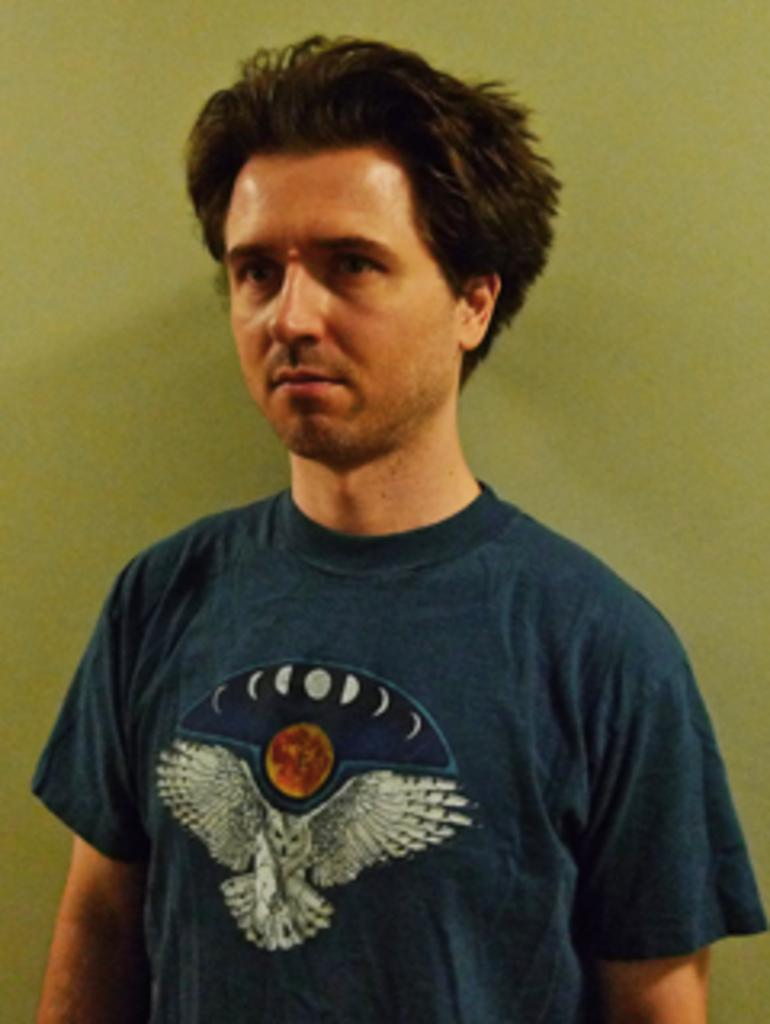Who is the main subject in the image? There is a person in the center of the image. What is the person wearing? The person is wearing a t-shirt. Can you describe the design on the t-shirt? There is an image of a bird on the t-shirt. What can be seen in the background of the image? There is a wall in the background of the image. What type of wilderness can be seen in the image? There is no wilderness present in the image; it features a person wearing a t-shirt with a bird image in front of a wall. 